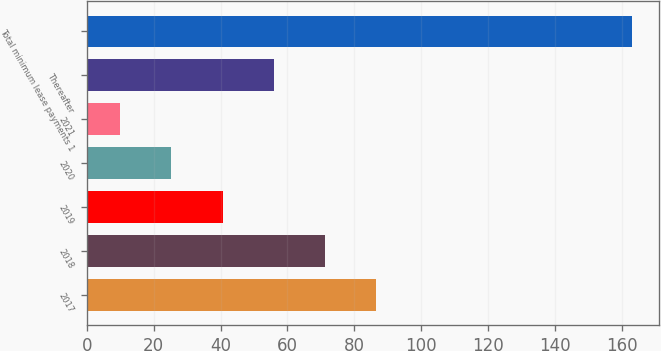<chart> <loc_0><loc_0><loc_500><loc_500><bar_chart><fcel>2017<fcel>2018<fcel>2019<fcel>2020<fcel>2021<fcel>Thereafter<fcel>Total minimum lease payments 1<nl><fcel>86.5<fcel>71.2<fcel>40.6<fcel>25.3<fcel>10<fcel>55.9<fcel>163<nl></chart> 